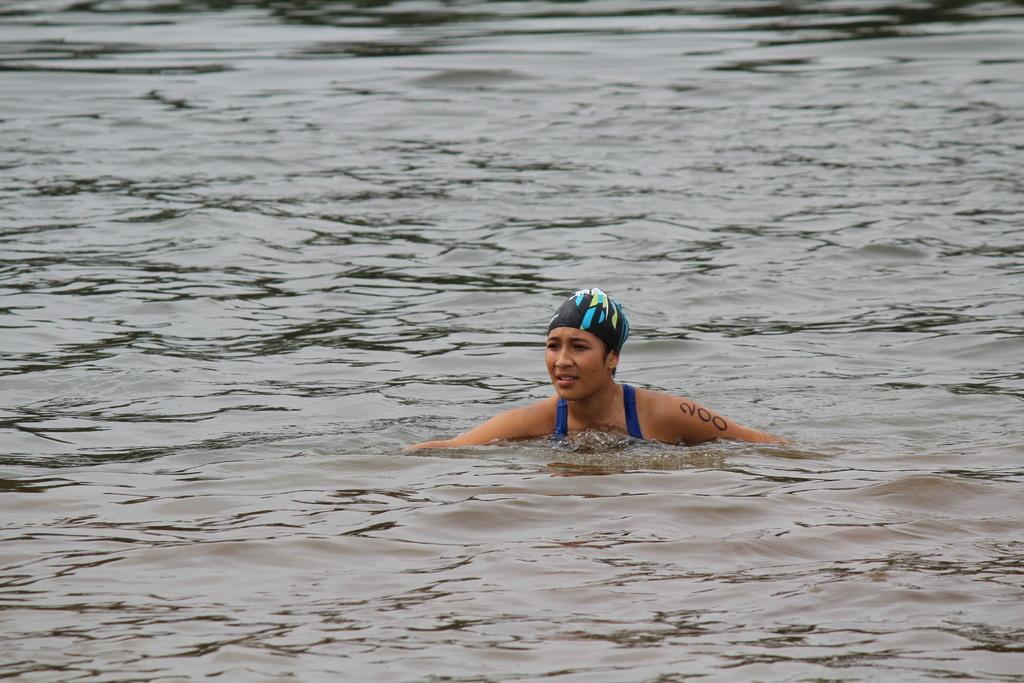Who is the main subject in the image? There is a girl in the image. What is the girl doing in the image? The girl is swimming in the water. What type of flock can be seen flying over the girl in the image? There is no flock visible in the image; the girl is swimming in the water. What type of clouds can be seen in the image? The provided facts do not mention any clouds in the image. 